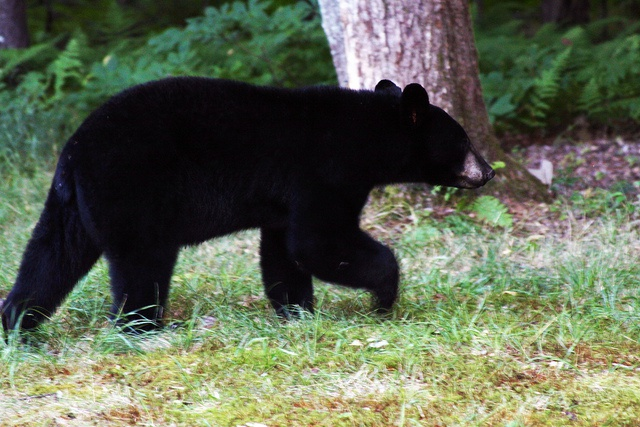Describe the objects in this image and their specific colors. I can see a bear in purple, black, gray, and navy tones in this image. 